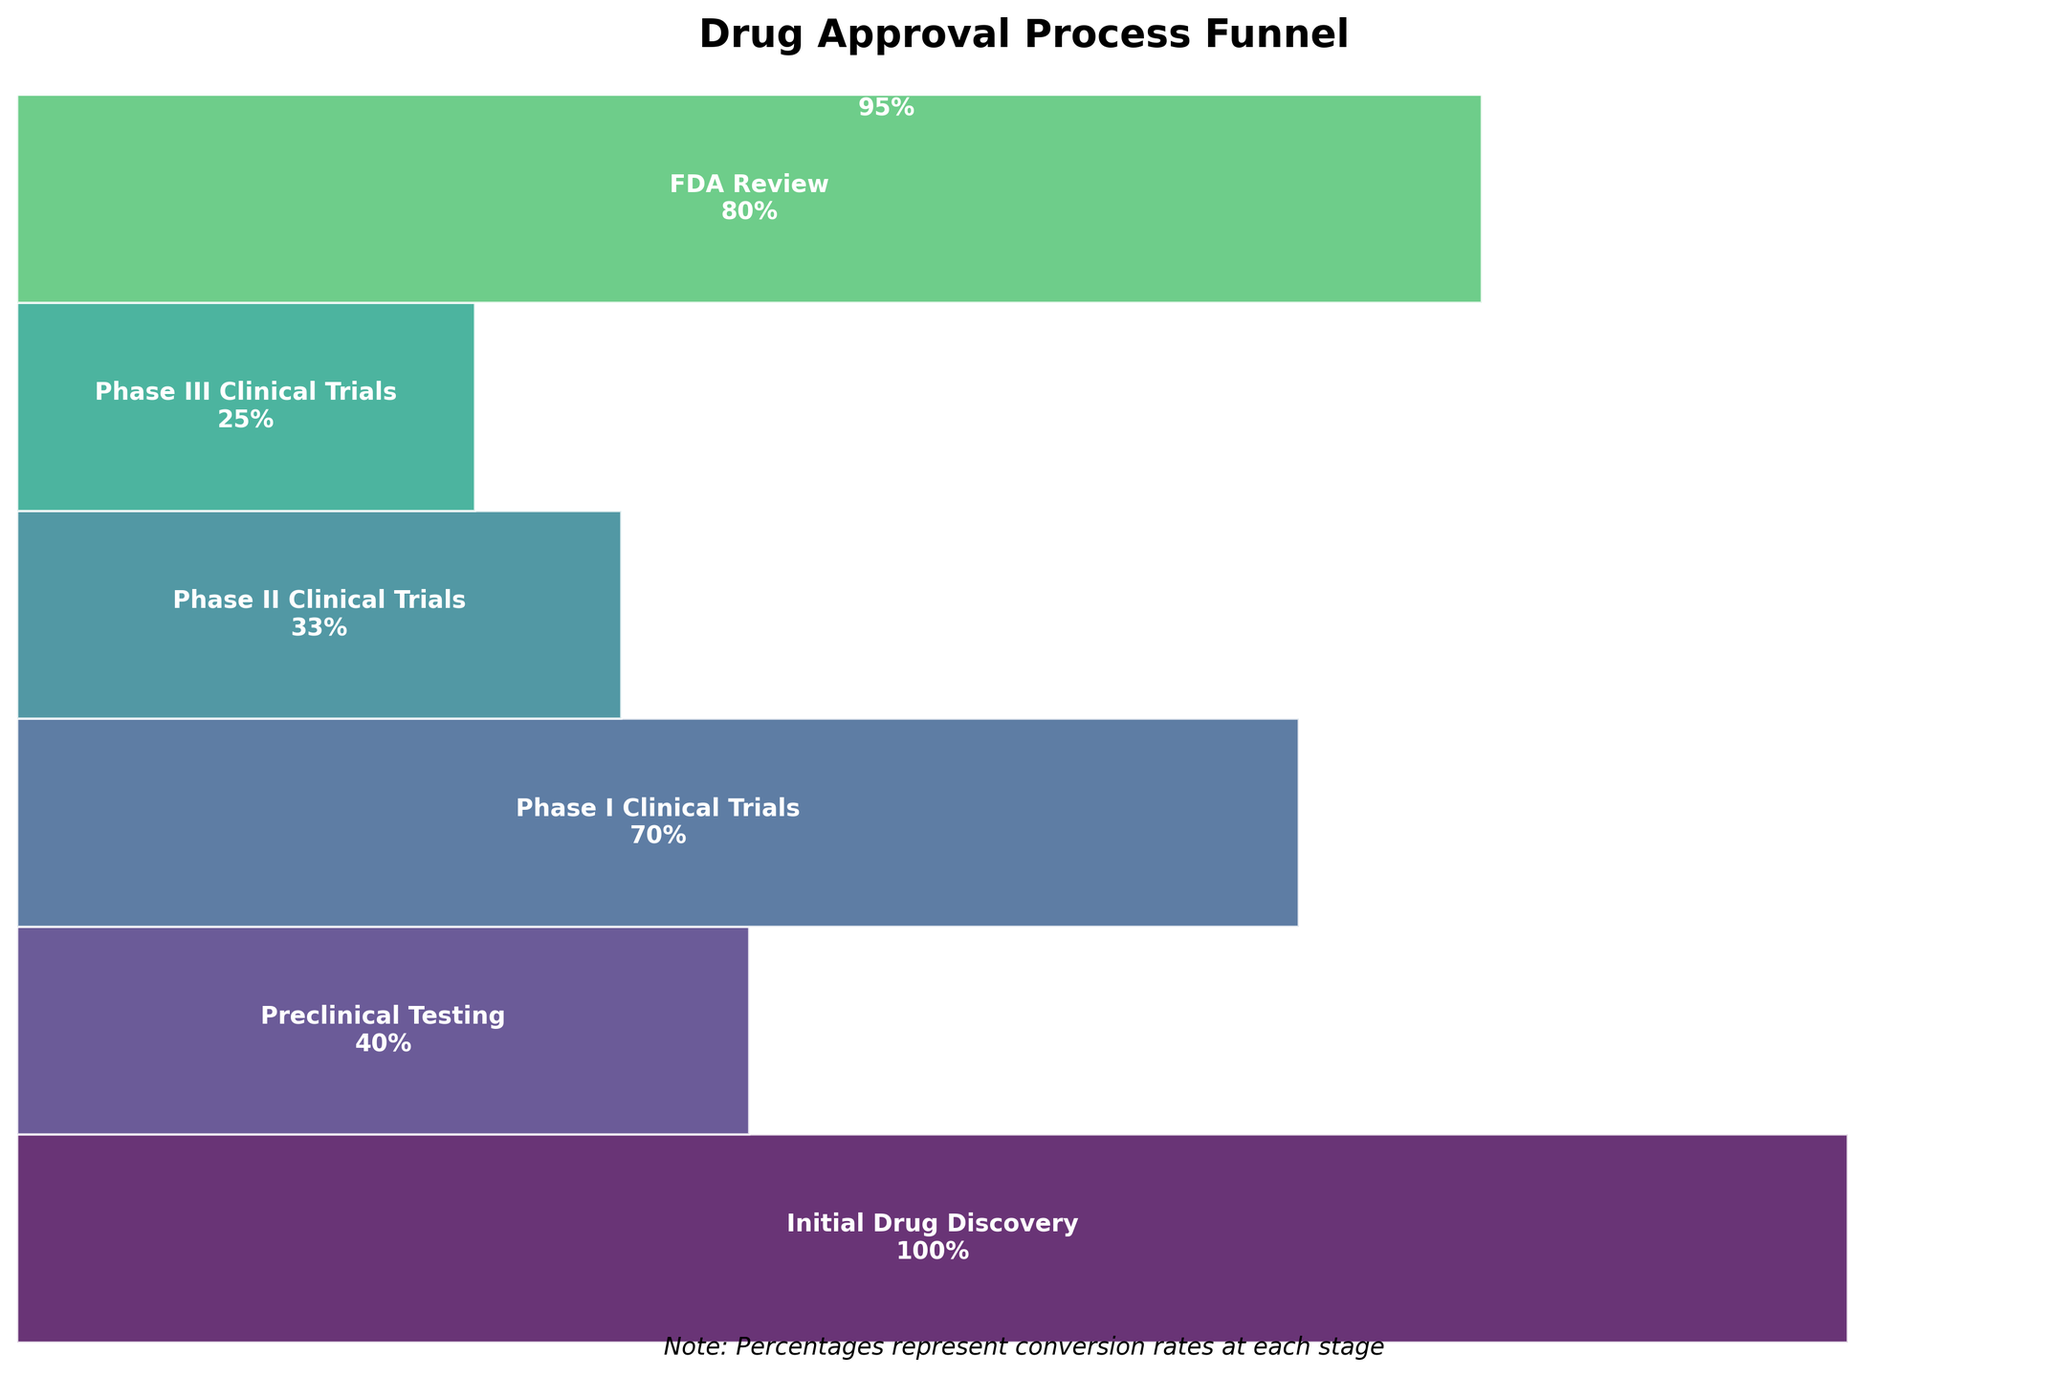What stages are represented in the funnel chart? The stages are labeled on the funnel sections, each representing a different phase of the drug approval process. By reading these labels, one can identify all the stages.
Answer: Initial Drug Discovery, Preclinical Testing, Phase I Clinical Trials, Phase II Clinical Trials, Phase III Clinical Trials, FDA Review, Post-Market Safety Monitoring What is the title of the funnel chart? The chart title is located at the top center of the funnel chart.
Answer: Drug Approval Process Funnel Which stage has the highest conversion rate after the initial drug discovery? Check the conversion rates listed next to each stage on the chart, and find the highest one (excluding the initial 100% stage).
Answer: Post-Market Safety Monitoring What is the conversion rate from Preclinical Testing to Phase I Clinical Trials? Look at the conversion rate percentages listed on the funnel sections for these stages and calculate the rate drop.
Answer: 30% Which stage comes immediately after Phase II Clinical Trials? The stages are listed sequentially on the funnel; find the stage that follows Phase II Clinical Trials.
Answer: Phase III Clinical Trials Between Phase I and Phase II Clinical Trials, which has the lower conversion rate? Compare the conversion rates labeled on the funnel sections for these two stages to see which one is lower.
Answer: Phase II Clinical Trials What is the difference between the conversion rates of Preclinical Testing and Phase III Clinical Trials? Subtract the conversion rate of Phase III Clinical Trials from that of Preclinical Testing. Conversion rates are 40% and 25% respectively, so (40% - 25%).
Answer: 15% How does the conversion rate of FDA Review compare to that of Preclinical Testing? Compare the conversion rates of FDA Review and Preclinical Testing by reading the percentages on the funnel chart.
Answer: FDA Review has a higher conversion rate What's the average conversion rate across all stages except the initial drug discovery? Sum the conversion rates of all stages from Preclinical Testing to Post-Market Safety Monitoring and divide by the number of stages (6 stages): (40% + 70% + 33% + 25% + 80% + 95%) / 6.
Answer: 57.17% Which two stages have a conversion rate above 90%? Identify the stages whose conversion rates exceed 90% by examining the data provided on the chart.
Answer: Initial Drug Discovery, Post-Market Safety Monitoring 